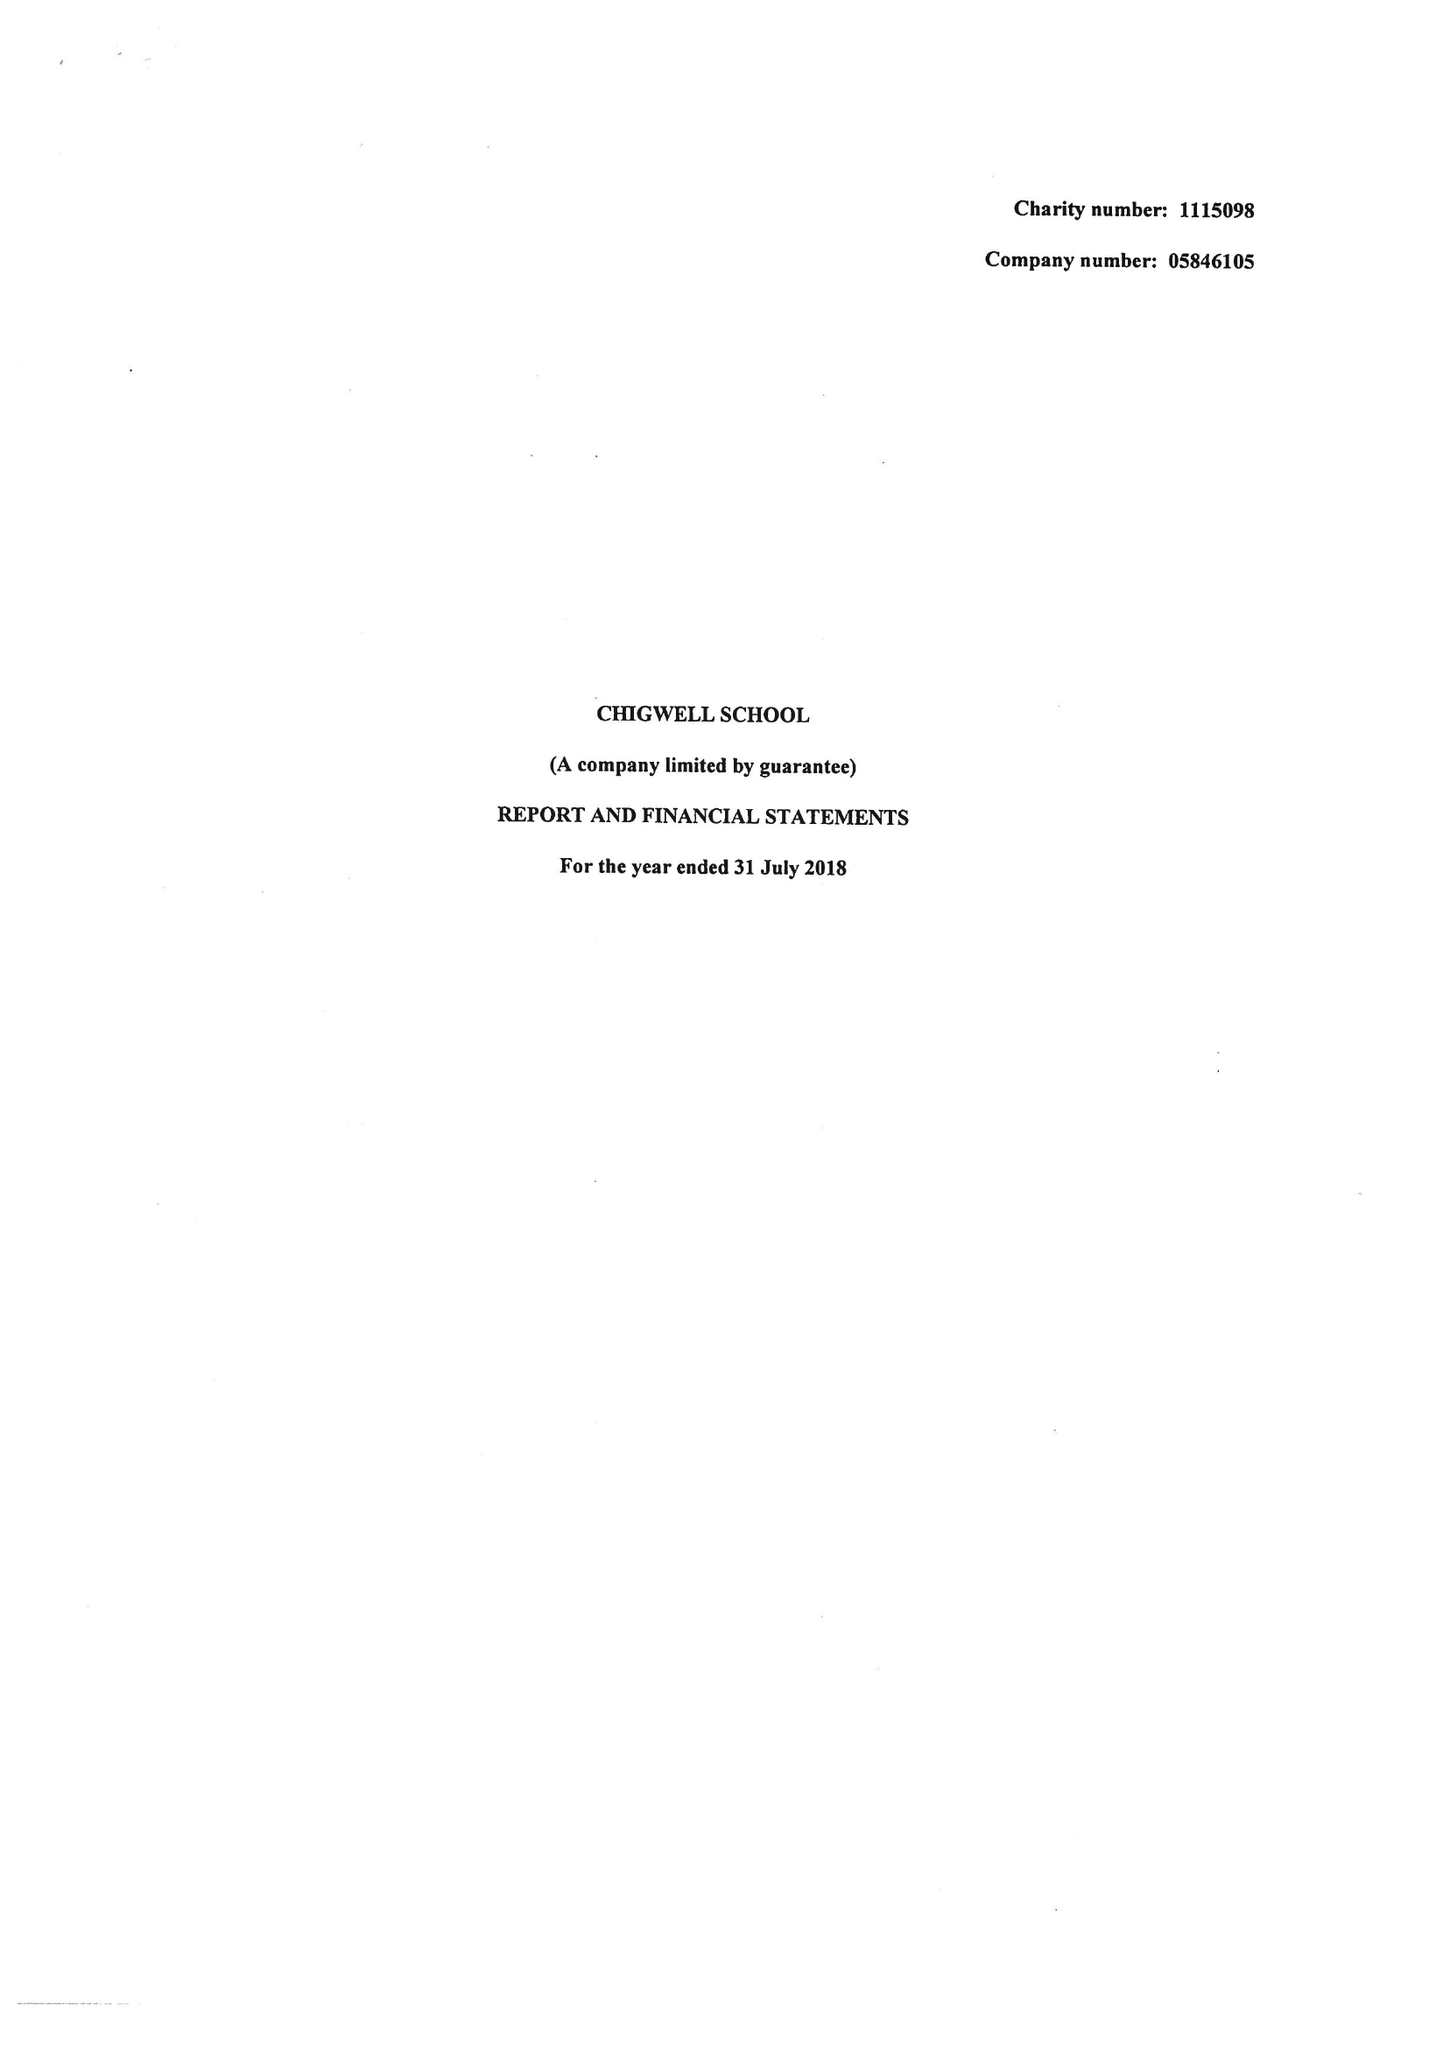What is the value for the address__postcode?
Answer the question using a single word or phrase. IG7 6QF 